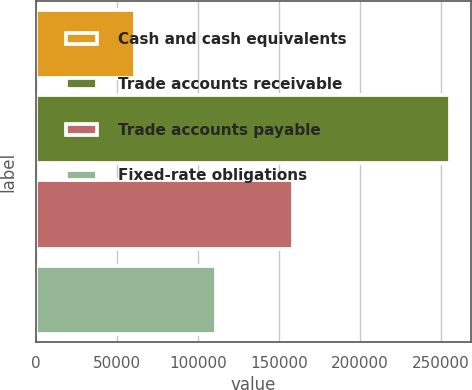<chart> <loc_0><loc_0><loc_500><loc_500><bar_chart><fcel>Cash and cash equivalents<fcel>Trade accounts receivable<fcel>Trade accounts payable<fcel>Fixed-rate obligations<nl><fcel>61229<fcel>256032<fcel>158886<fcel>111003<nl></chart> 